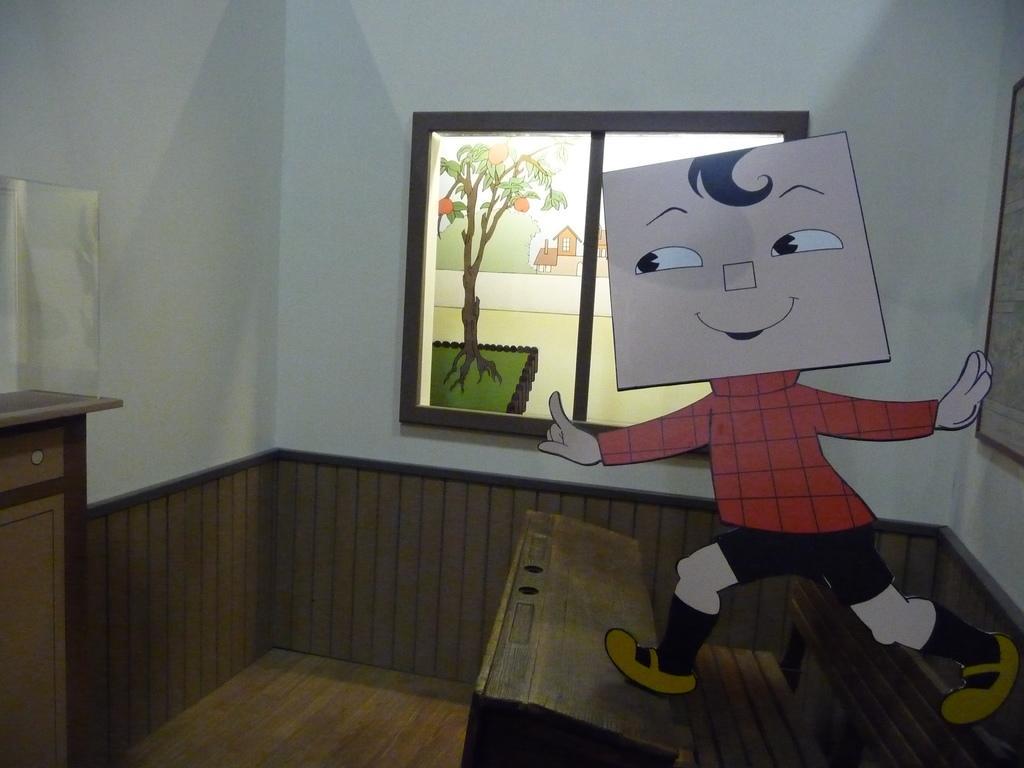In one or two sentences, can you explain what this image depicts? In this picture there is a window in the center of the image and there is a portrait on the right side of the image and there is a cartoon character on the right side of the image. 